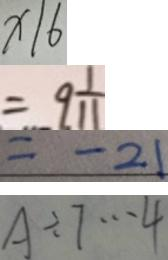<formula> <loc_0><loc_0><loc_500><loc_500>x / 6 
 = 9 \frac { 1 } { 1 1 } 
 = - 2 1 
 A \div 7 \cdots 4</formula> 